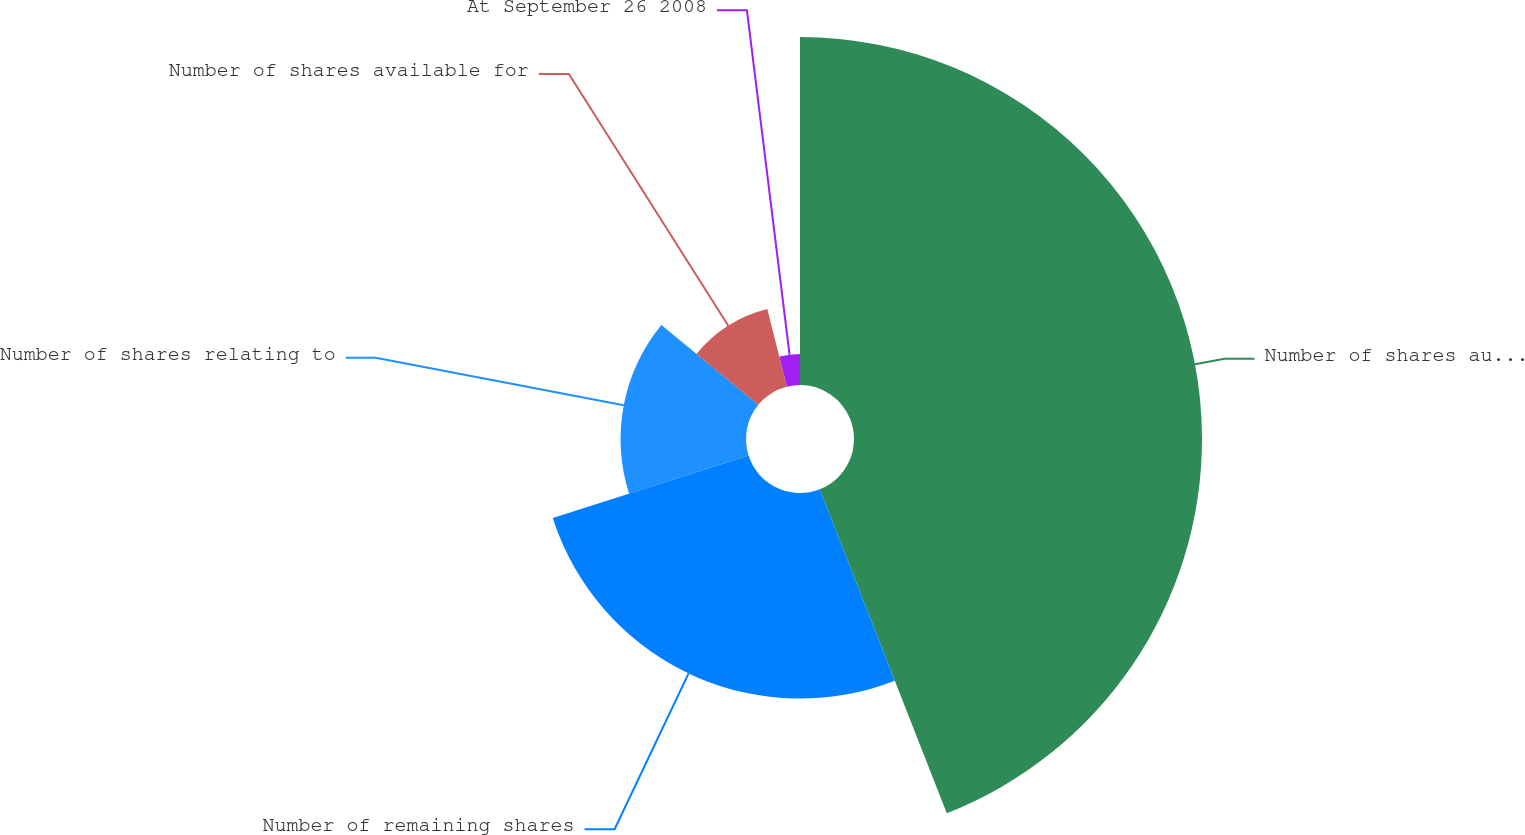<chart> <loc_0><loc_0><loc_500><loc_500><pie_chart><fcel>Number of shares authorized<fcel>Number of remaining shares<fcel>Number of shares relating to<fcel>Number of shares available for<fcel>At September 26 2008<nl><fcel>44.05%<fcel>26.02%<fcel>15.88%<fcel>10.13%<fcel>3.92%<nl></chart> 